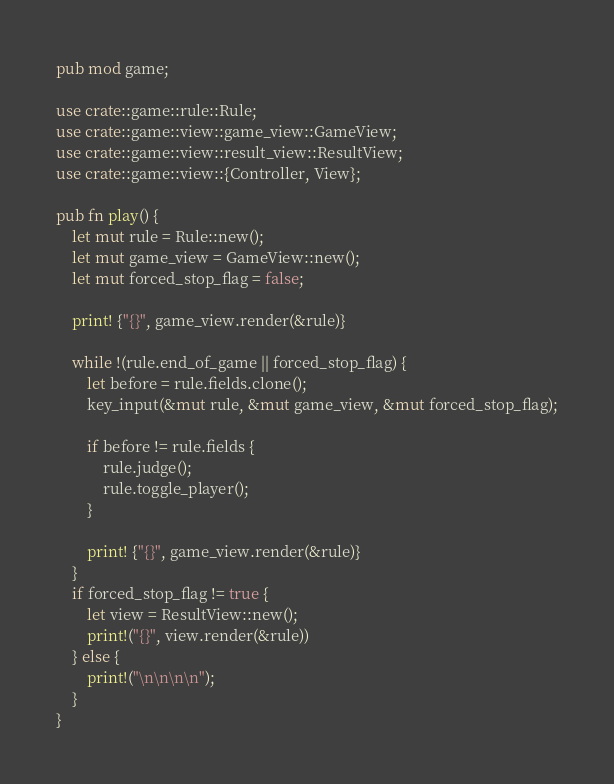<code> <loc_0><loc_0><loc_500><loc_500><_Rust_>pub mod game;

use crate::game::rule::Rule;
use crate::game::view::game_view::GameView;
use crate::game::view::result_view::ResultView;
use crate::game::view::{Controller, View};

pub fn play() {
    let mut rule = Rule::new();
    let mut game_view = GameView::new();
    let mut forced_stop_flag = false;

    print! {"{}", game_view.render(&rule)}

    while !(rule.end_of_game || forced_stop_flag) {
        let before = rule.fields.clone();
        key_input(&mut rule, &mut game_view, &mut forced_stop_flag);

        if before != rule.fields {
            rule.judge();
            rule.toggle_player();
        }

        print! {"{}", game_view.render(&rule)}
    }
    if forced_stop_flag != true {
        let view = ResultView::new();
        print!("{}", view.render(&rule))
    } else {
        print!("\n\n\n\n");
    }
}
</code> 